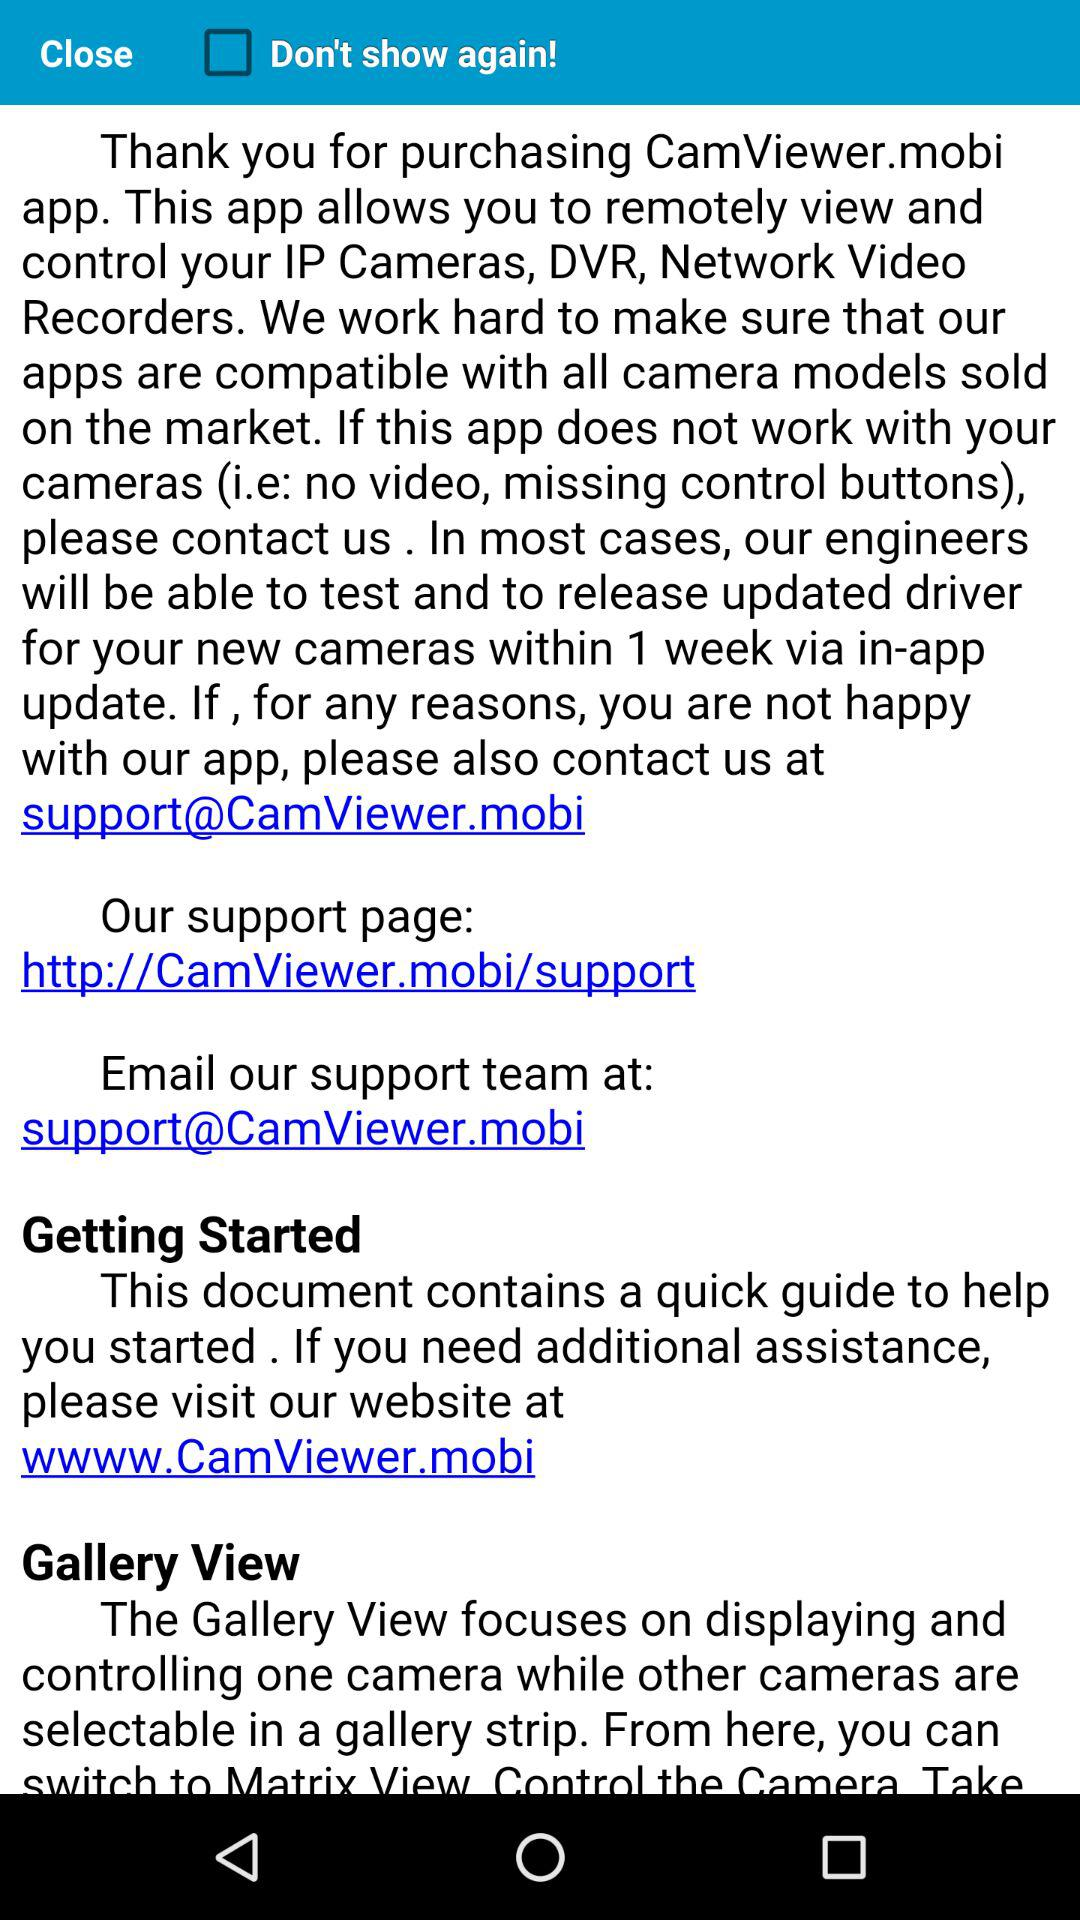What is the status of "Don't show again!"? The status is "off". 